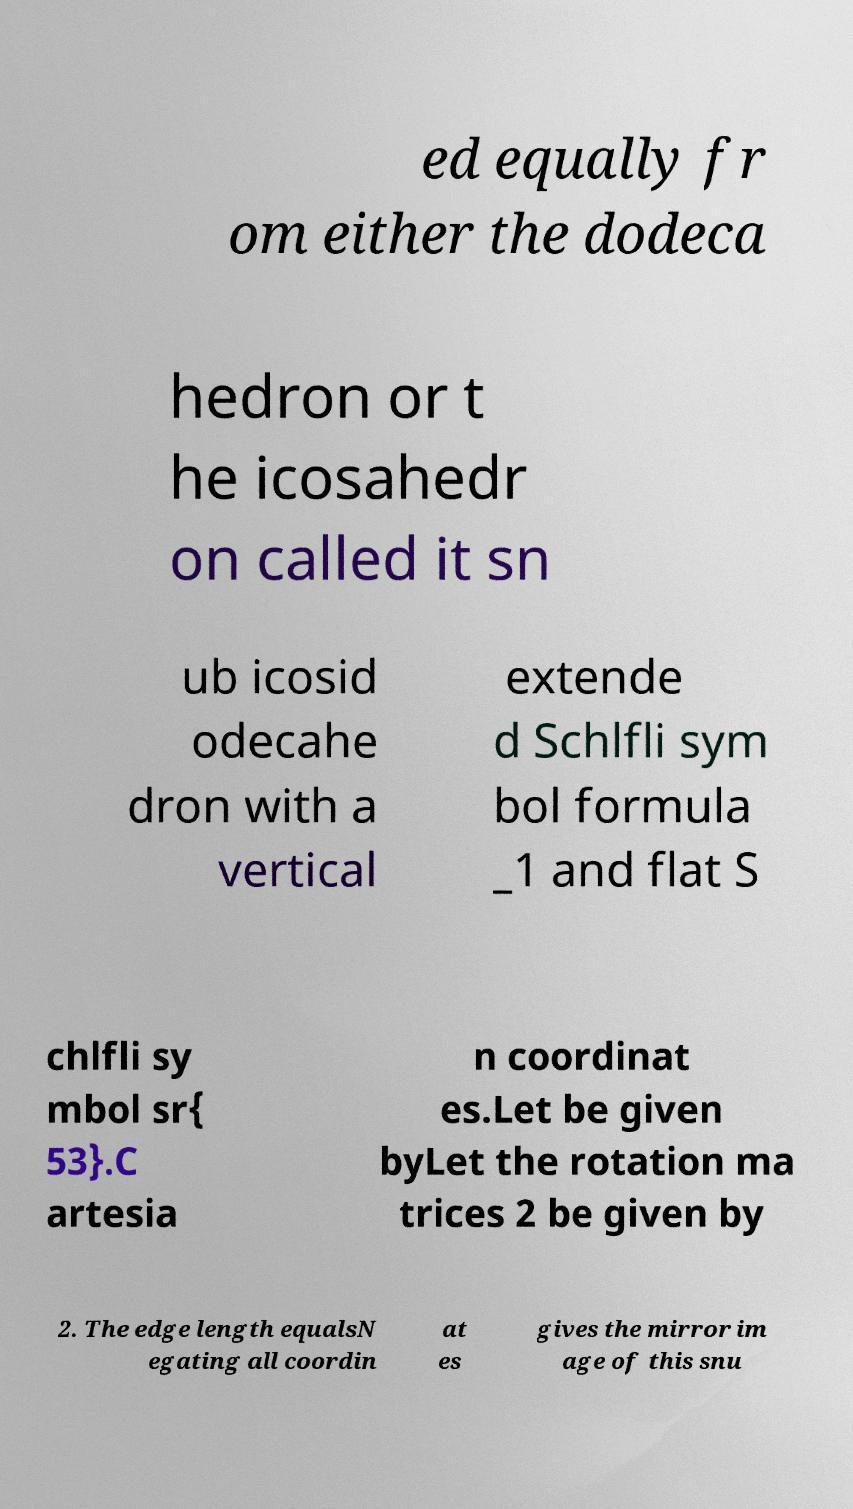Please identify and transcribe the text found in this image. ed equally fr om either the dodeca hedron or t he icosahedr on called it sn ub icosid odecahe dron with a vertical extende d Schlfli sym bol formula _1 and flat S chlfli sy mbol sr{ 53}.C artesia n coordinat es.Let be given byLet the rotation ma trices 2 be given by 2. The edge length equalsN egating all coordin at es gives the mirror im age of this snu 